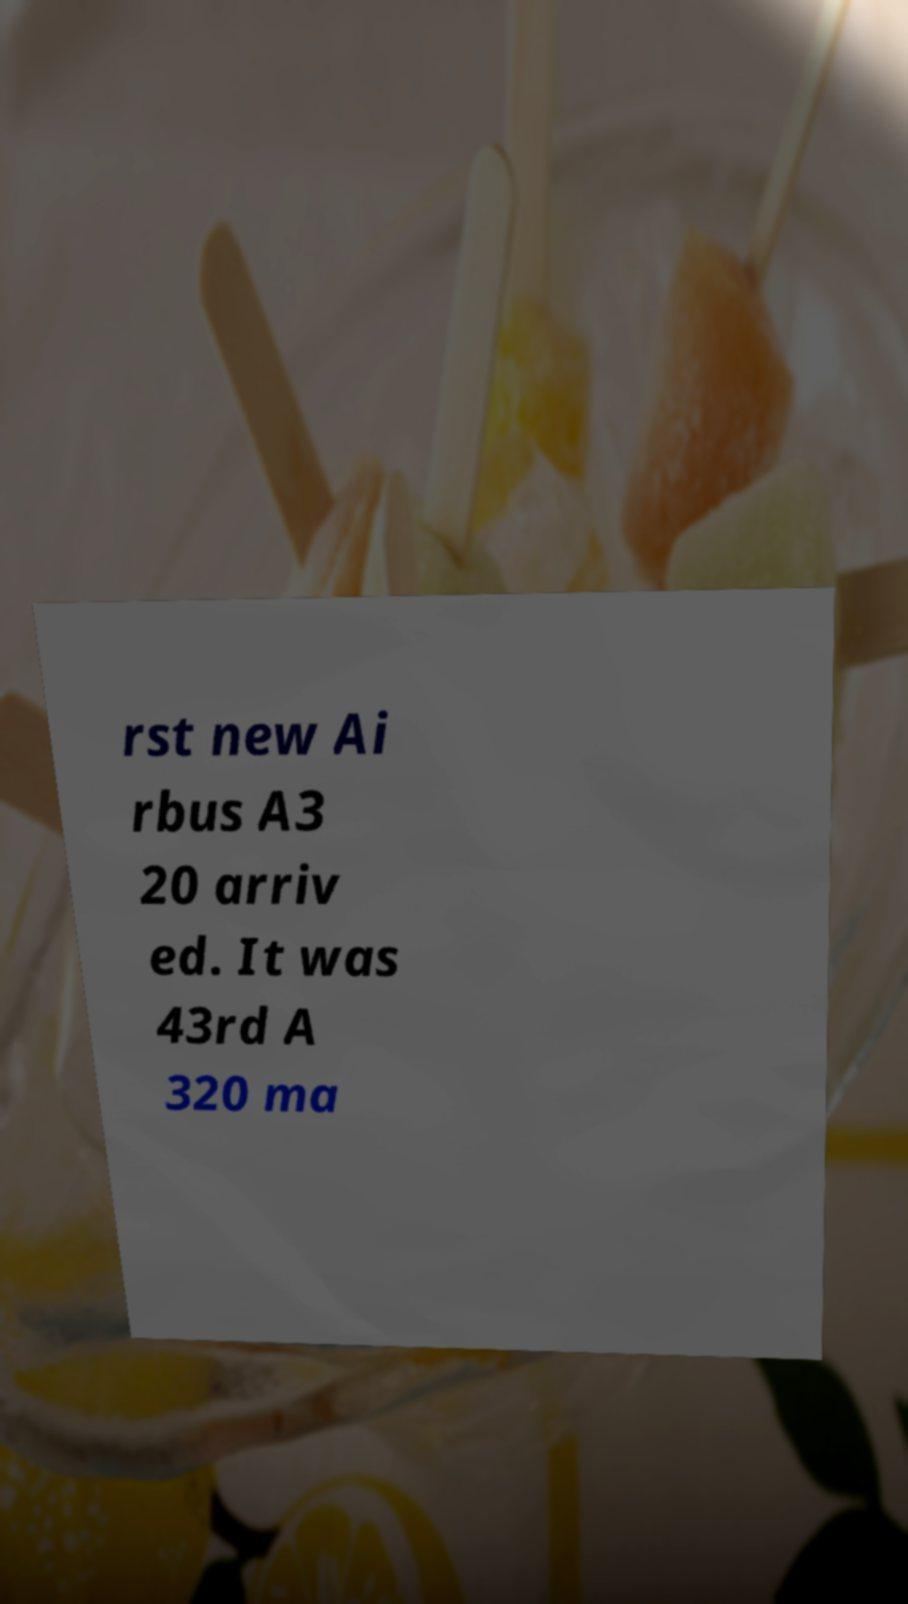I need the written content from this picture converted into text. Can you do that? rst new Ai rbus A3 20 arriv ed. It was 43rd A 320 ma 